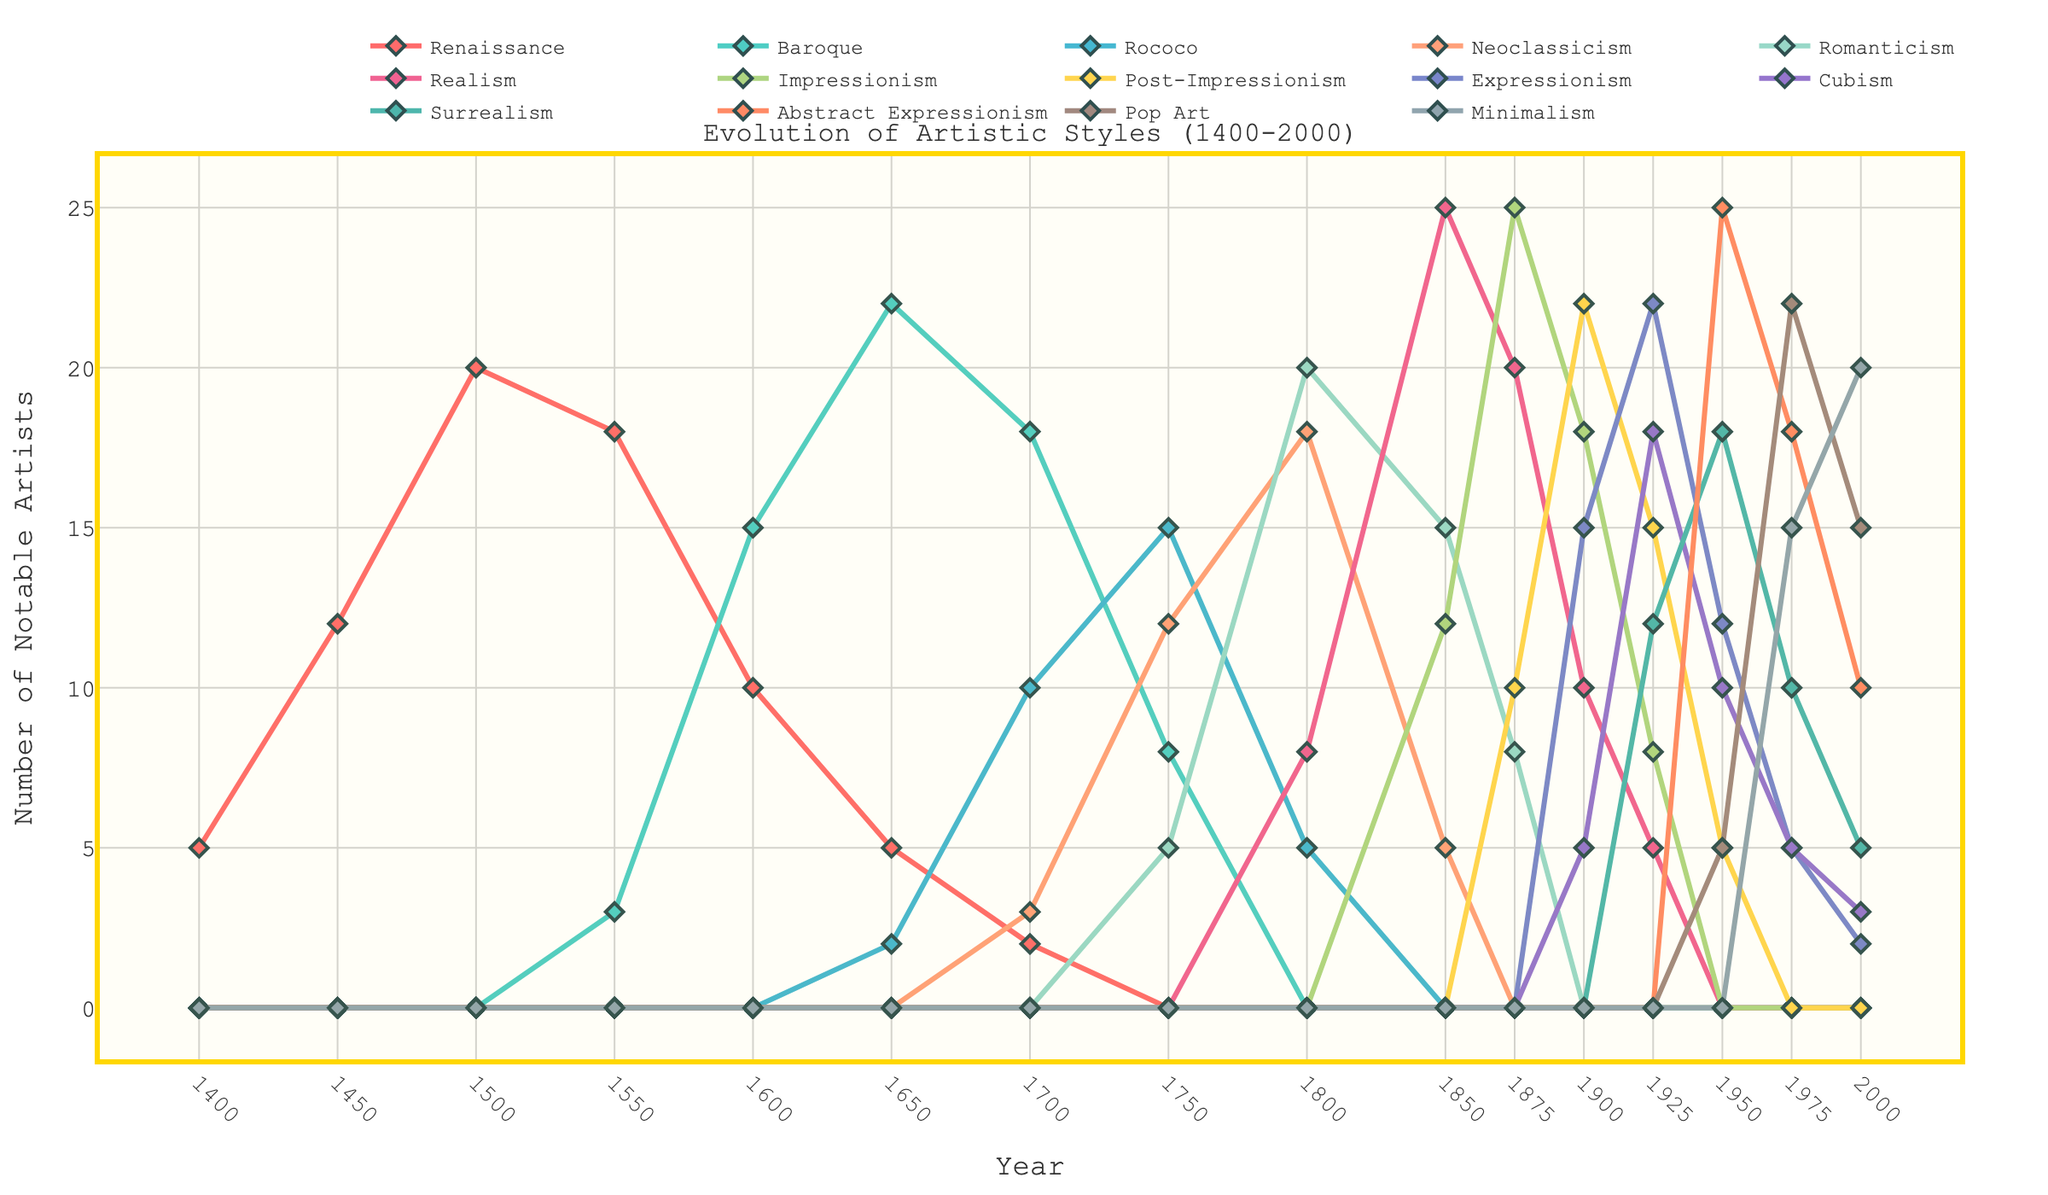Which art style had the most notable artists in 1875? Looking at the figure, near the year 1875, we can see that Impressionism has the highest peak, indicating the most notable artists at that time.
Answer: Impressionism During which period did the Baroque style have the most notable artists? Observing the heights of the Baroque line on the chart, the peak number of notable artists occurs around the year 1650.
Answer: 1650 How many notable artists were there in the Neoclassicism and Minimalism styles combined in the year 2000? Referring to the end of the figure (year 2000), Neoclassicism has 0 notable artists and Minimalism has 20. Summing these values gives us 0 + 20 = 20.
Answer: 20 Which art style remained relatively constant in terms of the number of notable artists between 1925 to 1950, and what was the approximate number? By examining the lines on the chart between 1925 to 1950, the line for Cubism shows relatively little change and hovers around 10 notable artists during that span.
Answer: Cubism, 10 How did the number of notable artists in Romanticism change between 1800 and 1850? Observing the chart between the years 1800 and 1850, the Romanticism line starts at 20 in 1800 and decreases to 15 by 1850, indicating a decrease of 5 notable artists.
Answer: Decreased by 5 Which art styles show a continuous decline from their peak? By tracing the chart lines, Renaissance and Rococo both show a continuous decline after their respective peaks.
Answer: Renaissance, Rococo In which year do we see the highest number of notable artists for Surrealism? Looking at the Surrealism line, the peak number of notable artists occurs around the year 1950.
Answer: 1950 Compare the number of artists in Abstract Expressionism and Pop Art in 1950. Which had more, and by how many? In 1950, the line for Abstract Expressionism is at 25 while Pop Art is at 5. So, Abstract Expressionism had 25 - 5 = 20 more artists.
Answer: Abstract Expressionism, 20 What is the difference between the number of notable artists in Expressionism at its peak and Cubism at its peak? The figure shows Expressionism peaks at 22 artists around 1925, while Cubism peaks at 18 artists around the same time. The difference is 22 - 18 = 4 artists.
Answer: 4 Which two art styles have similar numbers of notable artists around 1925? Observing the chart around 1925, both Expressionism and Cubism lines are close, Expressionism around 22 and Cubism around 18.
Answer: Expressionism and Cubism 